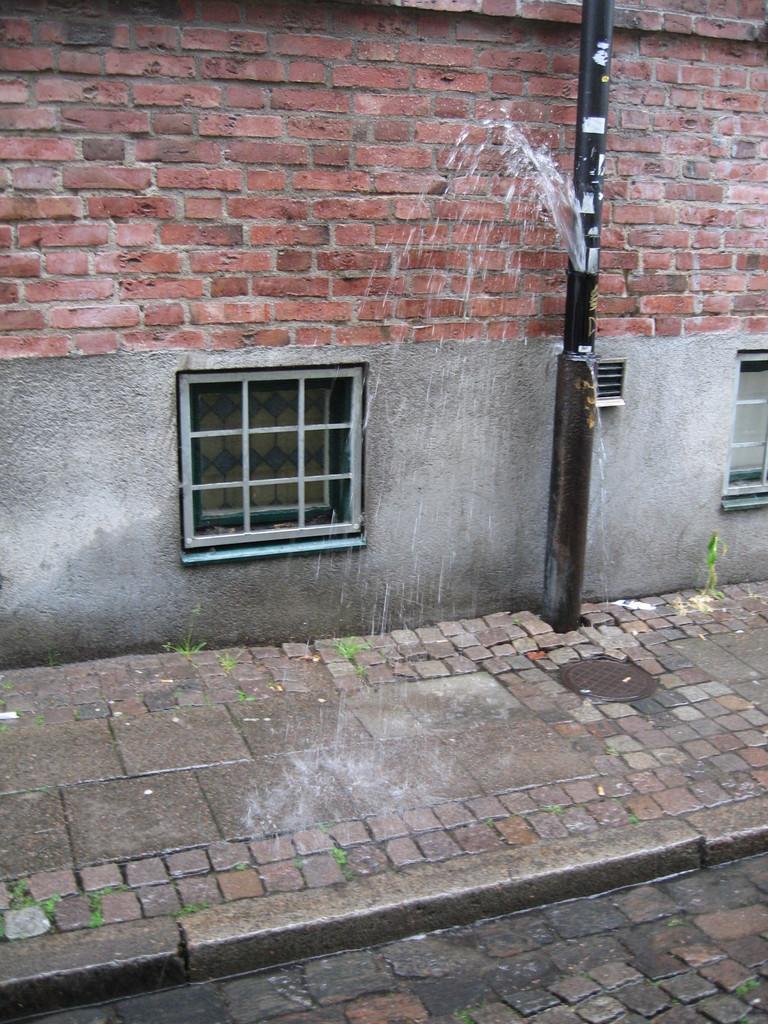In one or two sentences, can you explain what this image depicts? In the middle of the image there is a pole. Behind the pole there is a wall, on the wall there are some windows. 